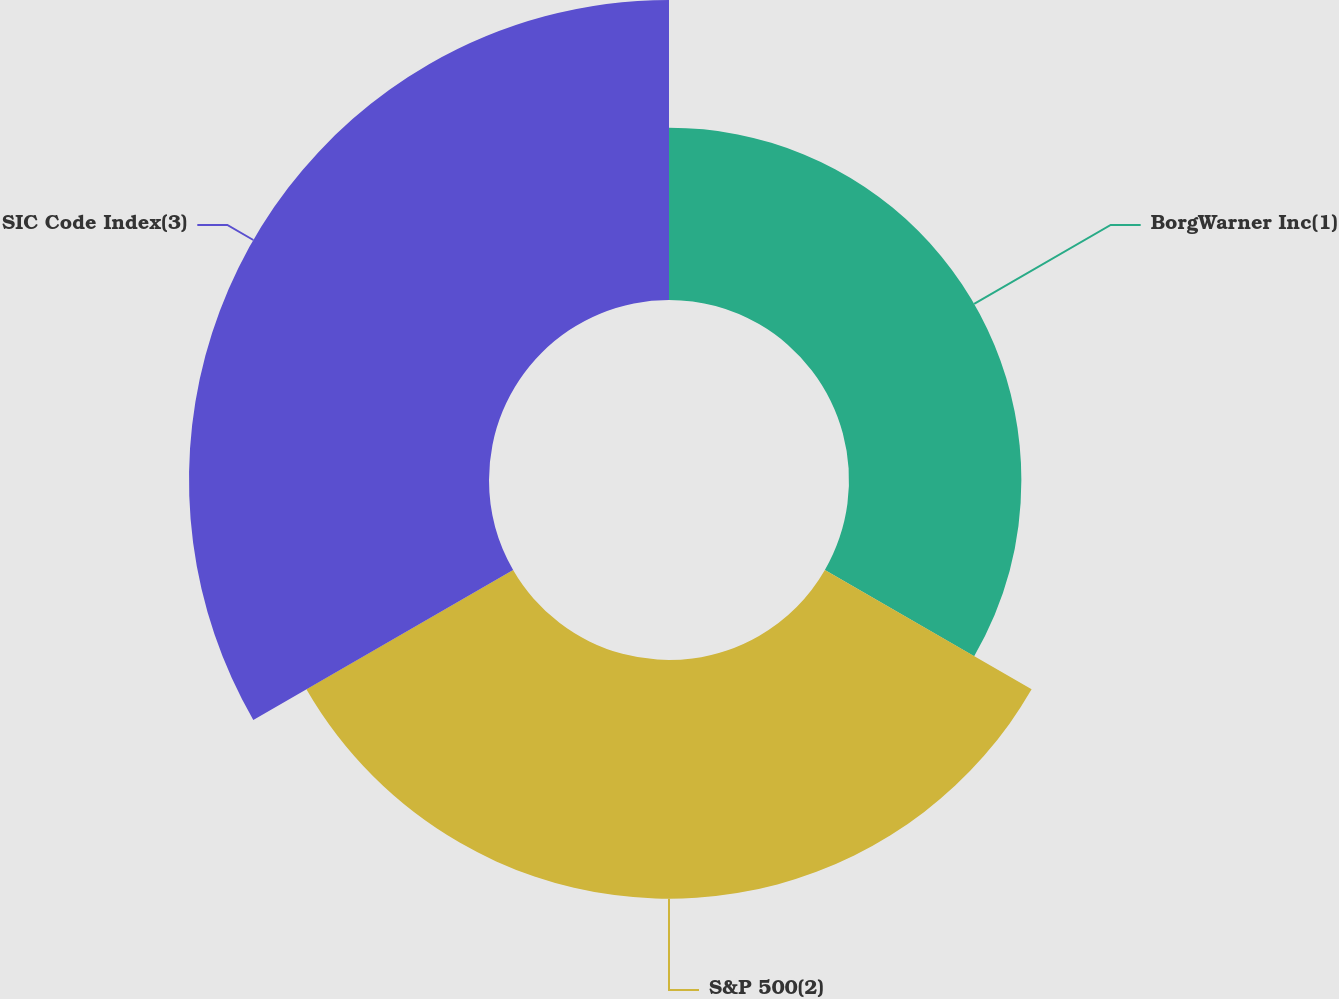<chart> <loc_0><loc_0><loc_500><loc_500><pie_chart><fcel>BorgWarner Inc(1)<fcel>S&P 500(2)<fcel>SIC Code Index(3)<nl><fcel>24.24%<fcel>33.57%<fcel>42.19%<nl></chart> 